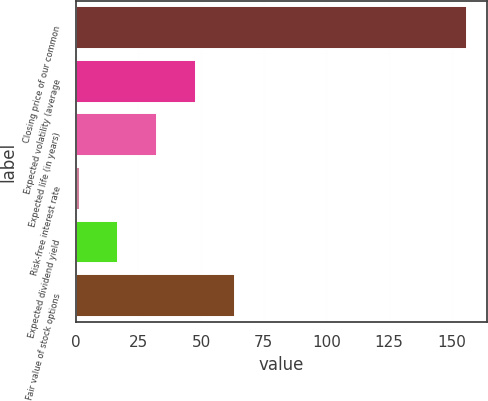Convert chart. <chart><loc_0><loc_0><loc_500><loc_500><bar_chart><fcel>Closing price of our common<fcel>Expected volatility (average<fcel>Expected life (in years)<fcel>Risk-free interest rate<fcel>Expected dividend yield<fcel>Fair value of stock options<nl><fcel>156.35<fcel>47.95<fcel>32.47<fcel>1.5<fcel>16.98<fcel>63.44<nl></chart> 